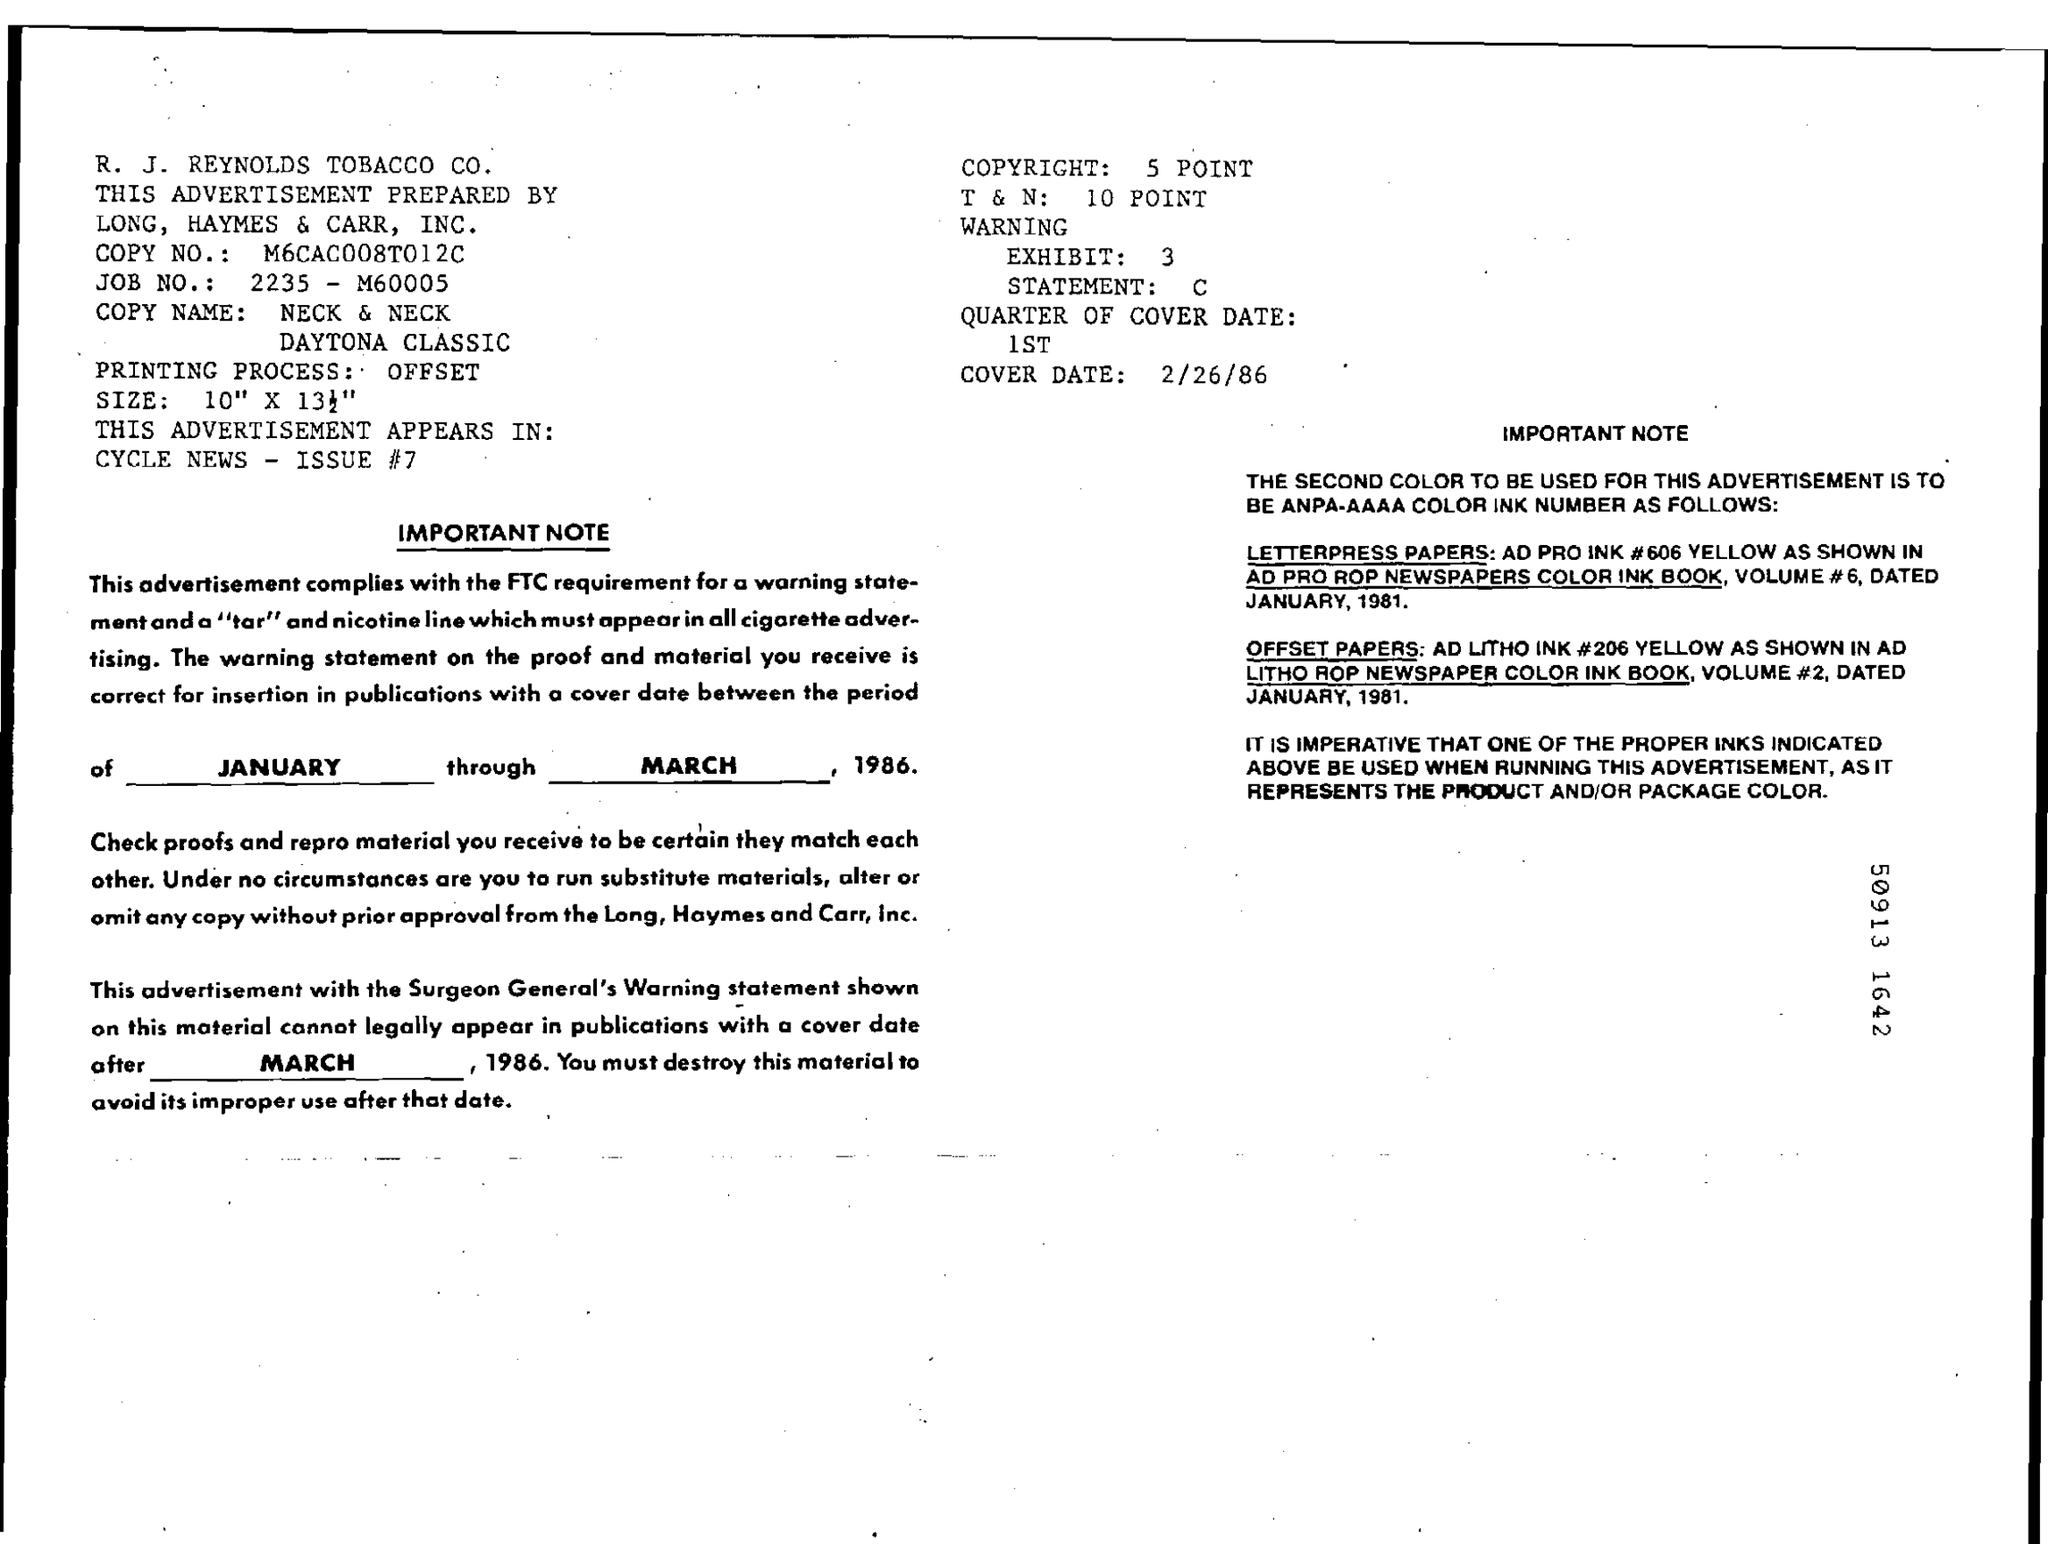Highlight a few significant elements in this photo. The cover date is February 26th, 1986. The job number is 2235-M60005. 